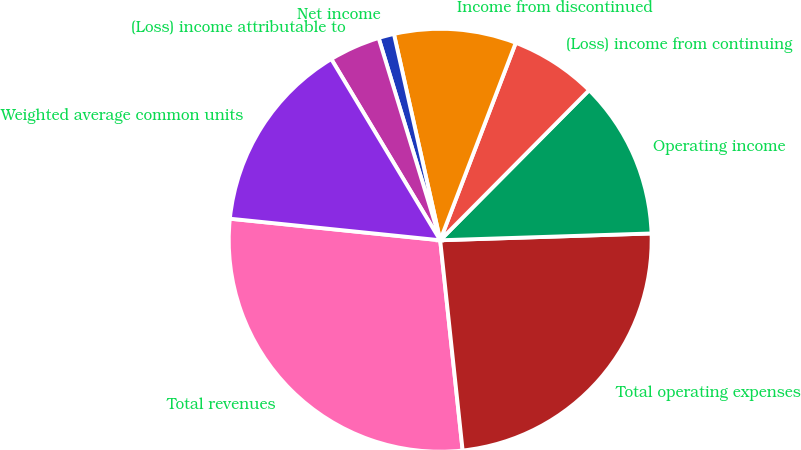<chart> <loc_0><loc_0><loc_500><loc_500><pie_chart><fcel>Total revenues<fcel>Total operating expenses<fcel>Operating income<fcel>(Loss) income from continuing<fcel>Income from discontinued<fcel>Net income<fcel>(Loss) income attributable to<fcel>Weighted average common units<nl><fcel>28.32%<fcel>23.82%<fcel>12.05%<fcel>6.62%<fcel>9.33%<fcel>1.19%<fcel>3.91%<fcel>14.76%<nl></chart> 